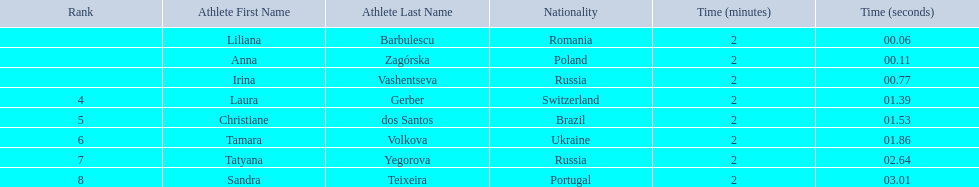Who are all of the athletes? Liliana Barbulescu, Anna Zagórska, Irina Vashentseva, Laura Gerber, Christiane dos Santos, Tamara Volkova, Tatyana Yegorova, Sandra Teixeira. What were their times in the heat? 2:00.06, 2:00.11, 2:00.77, 2:01.39, 2:01.53, 2:01.86, 2:02.64, 2:03.01. Of these, which is the top time? 2:00.06. Which athlete had this time? Liliana Barbulescu. 